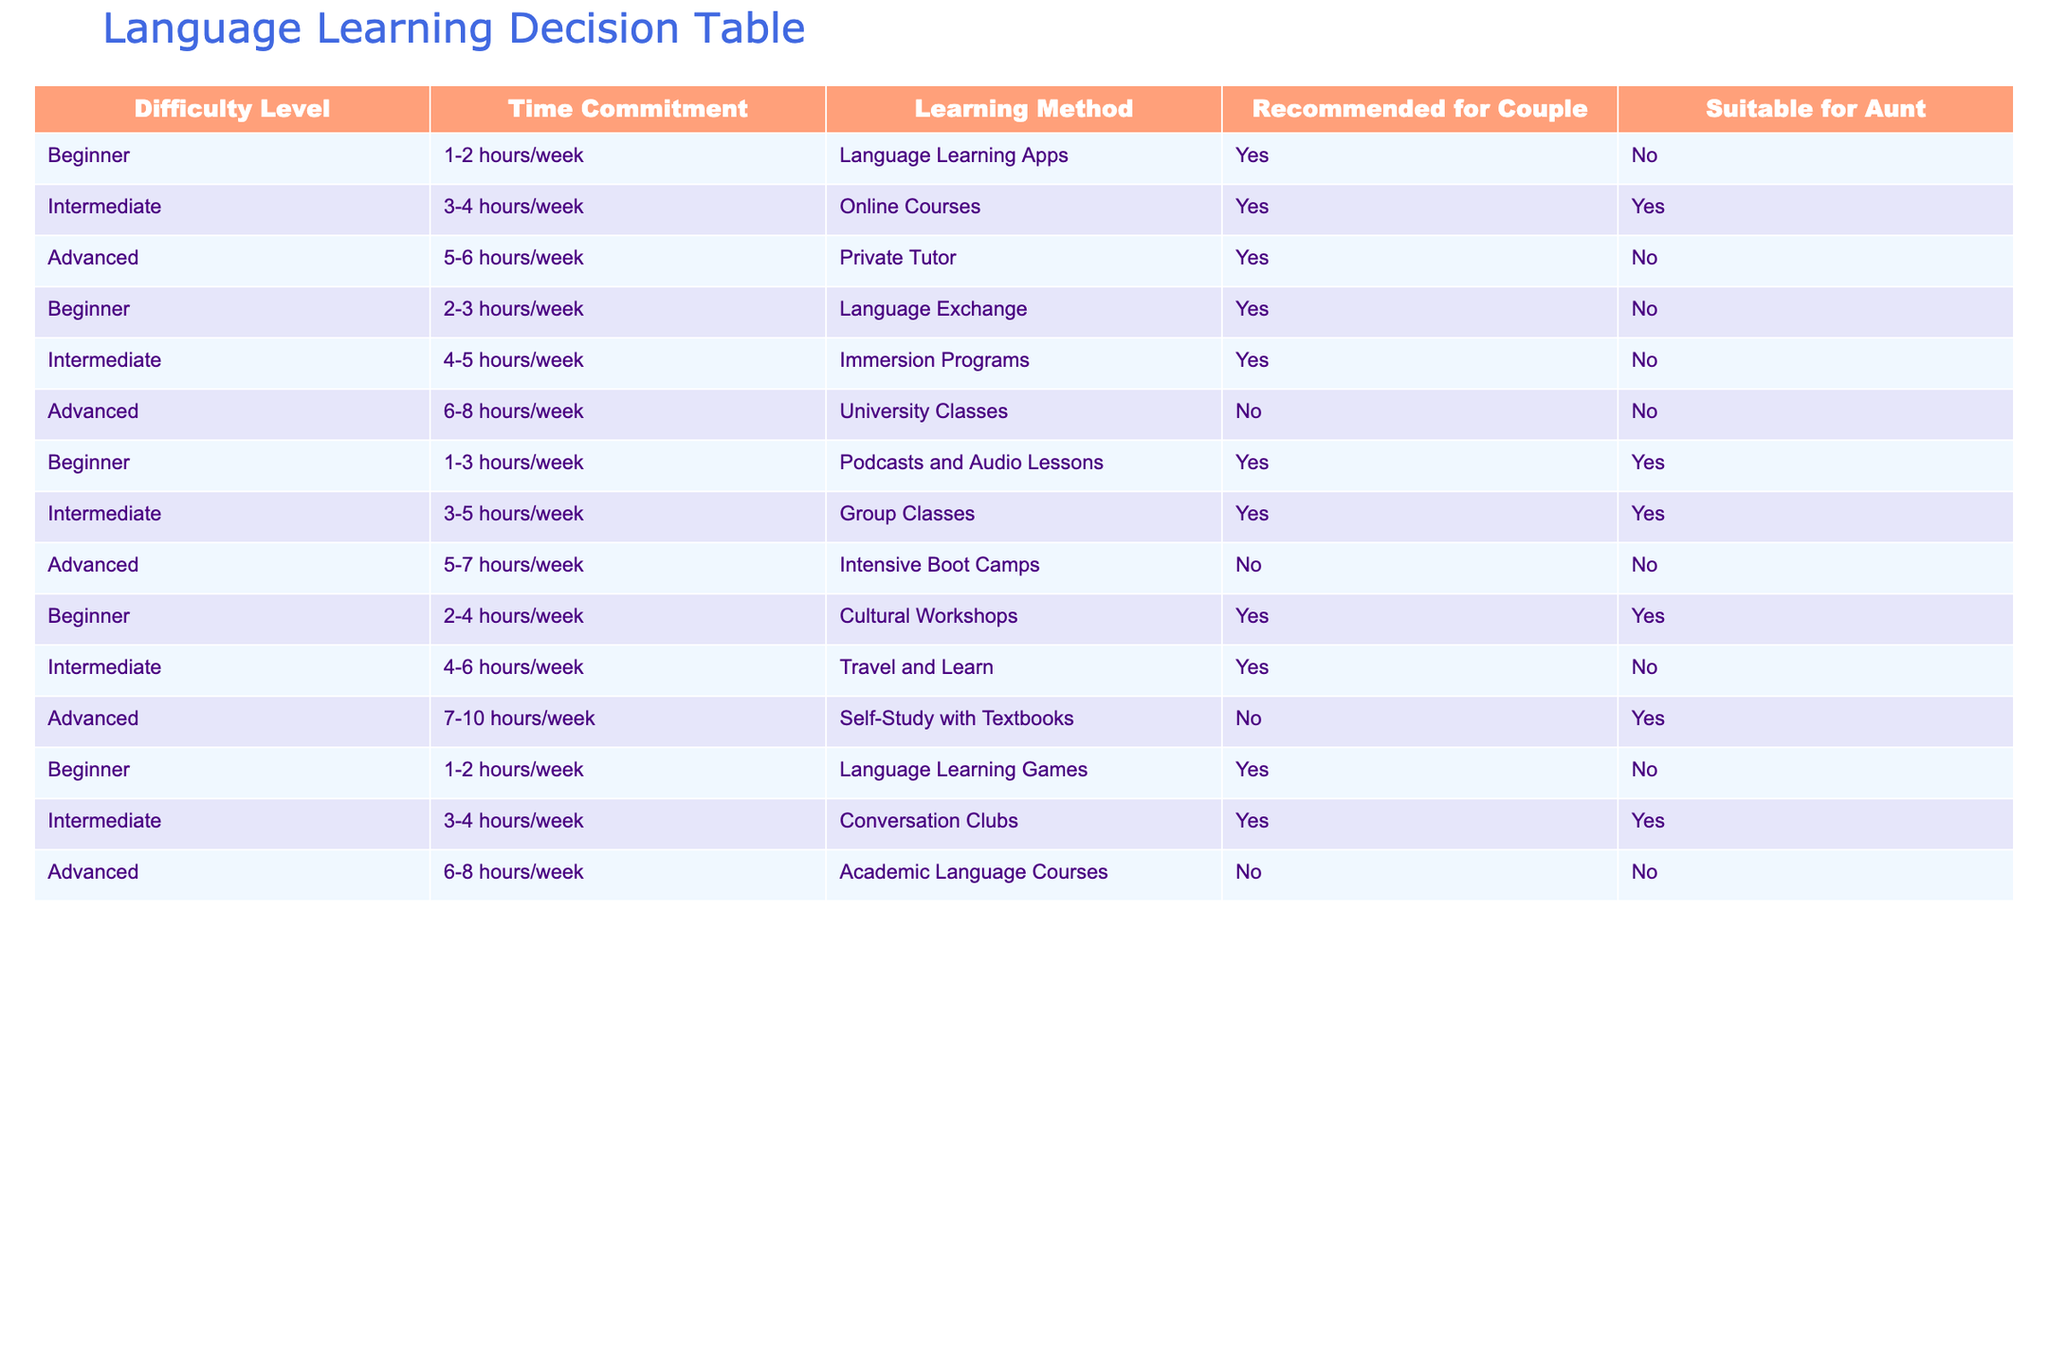What are the learning methods recommended for the couple with a Beginner level? By looking at the table, we can see the "Couple" column under the Beginner difficulty level. The methods listed there are: Language Learning Apps, Language Exchange, Podcasts and Audio Lessons, Cultural Workshops, and Language Learning Games. All these methods are marked with a "Yes," indicating they are suitable for the couple.
Answer: Language Learning Apps, Language Exchange, Podcasts and Audio Lessons, Cultural Workshops, Language Learning Games Which learning method has the highest time commitment for Intermediate learners that is recommended for both the couple and the aunt? To find this, we look for Intermediate methods with "Yes" under both the "Recommended for Couple" and "Suitable for Aunt" columns. The methods fitting this criteria are Online Courses and Group Classes. Among these, Group Classes has a time commitment of 3-5 hours/week and Online Courses has 3-4 hours/week. Group Classes has a higher range.
Answer: Group Classes Are there any methods suitable for the aunt that require more than 6 hours a week? We check the "Suitable for Aunt" column for "Yes" in methods with a time commitment greater than 6 hours. The only method that meets this criterion is Self-Study with Textbooks, which requires 7-10 hours/week and is suitable for the aunt.
Answer: Yes, Self-Study with Textbooks What is the average time commitment for all Beginner learning methods? We start by identifying the time commitments for all Beginner methods: 1-2 hours/week, 2-3 hours/week, 1-3 hours/week, 2-4 hours/week, and 1-2 hours/week. Converting these to a consistent unit, we can take the average of the midpoints: (1.5 + 2.5 + 2 + 3 + 1.5) / 5 = 2.1 hours/week (approximately).
Answer: 2.1 hours/week Is the Immersion Program suitable for the couple? Checking the "Recommended for Couple" column for the Immersion Programs entry, we find it is marked with "Yes." Therefore, it is suitable for the couple.
Answer: No 